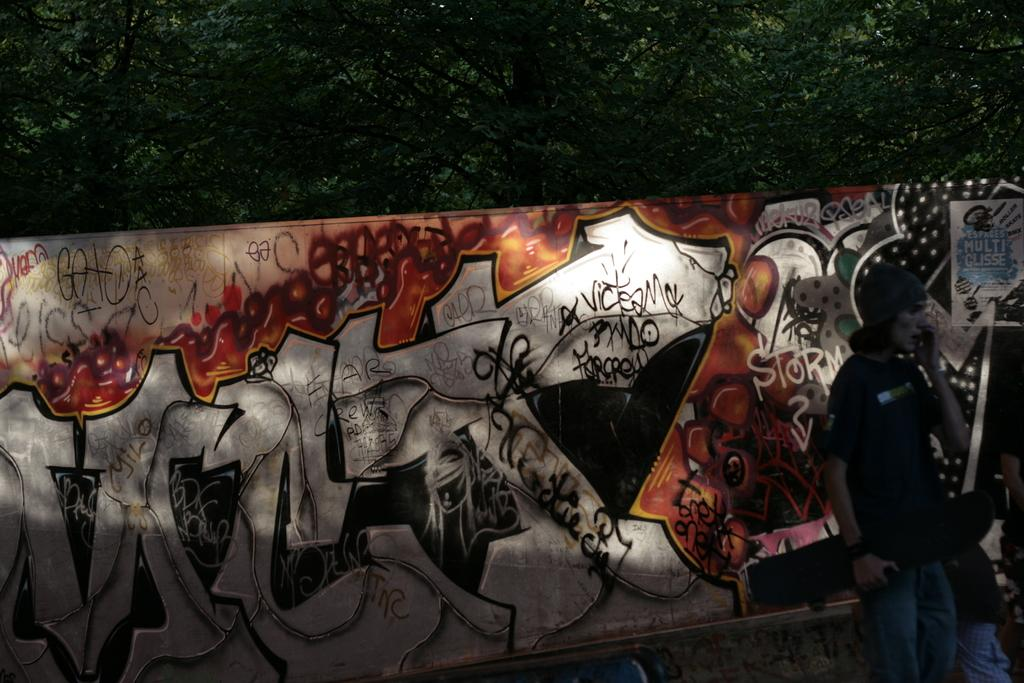What is the main subject of the image? There is a person standing in the image. What is the person wearing on their head? The person is wearing a cap. What color is the t-shirt the person is wearing? The person is wearing a black t-shirt. What can be seen behind the person in the image? There is an art wall behind the person. What type of natural scenery is visible at the back of the image? There are trees visible at the back of the image. What type of zipper can be seen on the person's t-shirt in the image? There is no visible zipper on the person's t-shirt in the image. What type of kite is the person flying in the image? There is no kite present in the image; the person is standing near an art wall and trees. 